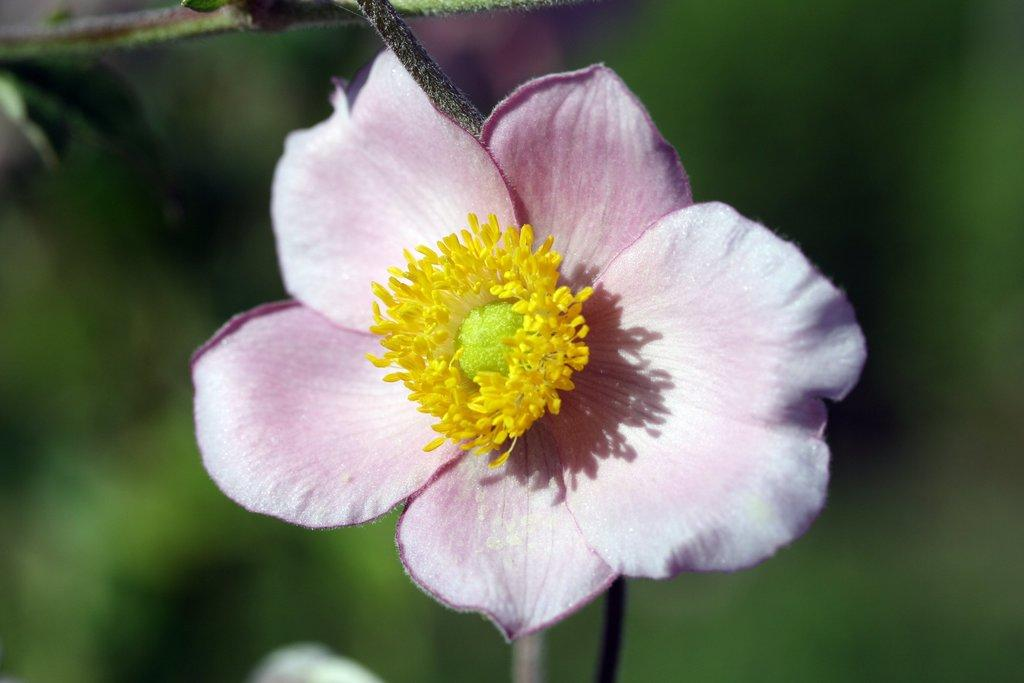What is the main subject of the image? There is a flower in the center of the image. Can you describe the flower in the image? The flower appears to be in full bloom, with petals of a certain color and shape. What might be the significance of the flower in the image? The flower could symbolize beauty, growth, or nature, depending on the context and the viewer's interpretation. What type of meat is being served in the image? There is no meat present in the image; it features a flower in the center. What is the source of humor in the image? There is no humor depicted in the image; it is a simple image of a flower. 